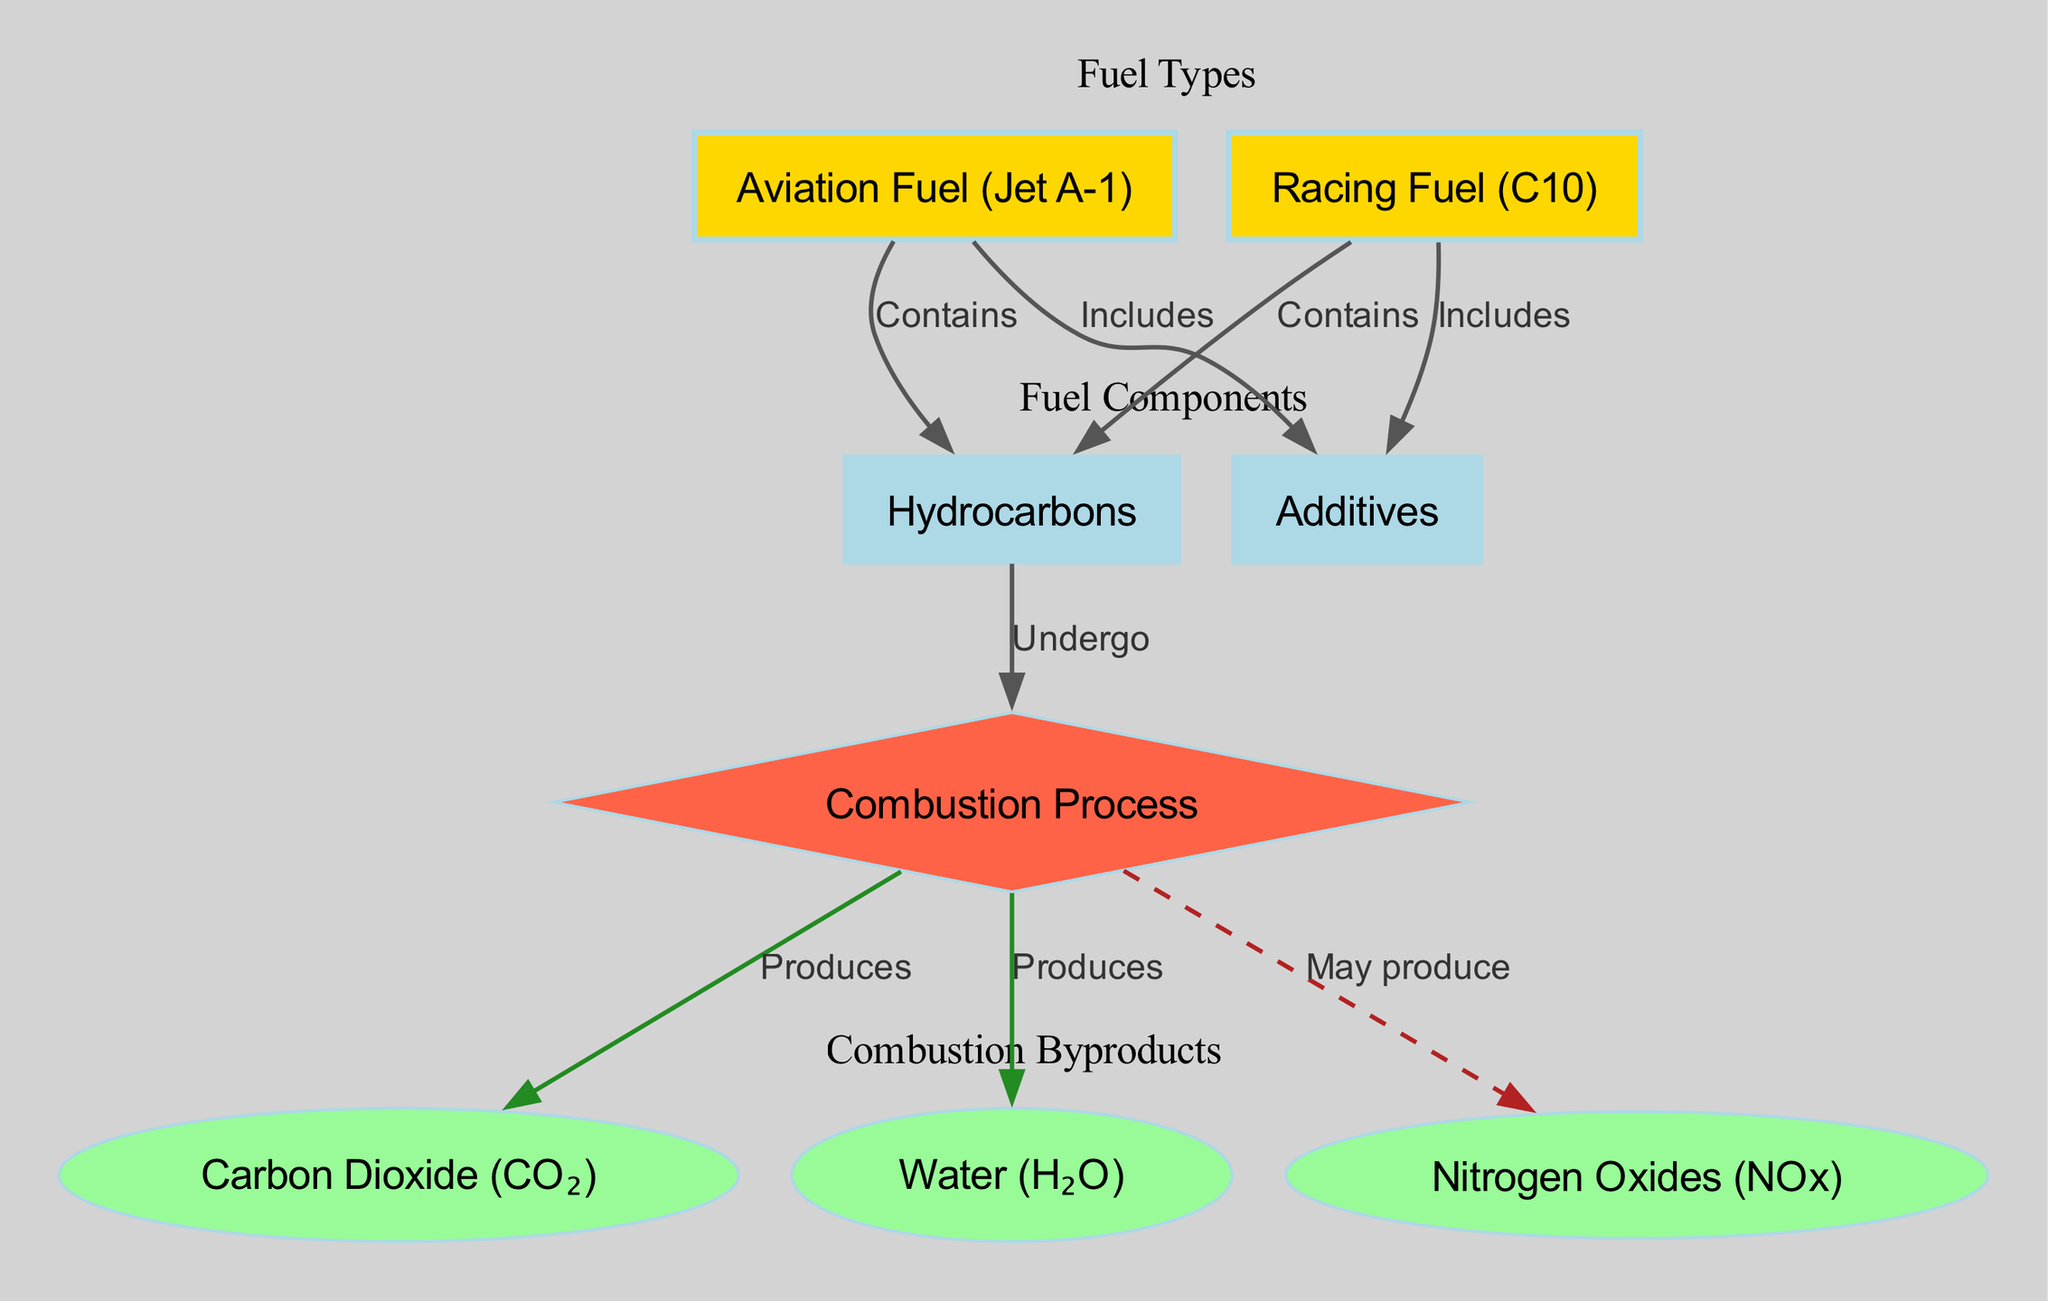What types of fuel are included in the diagram? The diagram lists two types of fuel: Aviation Fuel (Jet A-1) and Racing Fuel (C10). These nodes are distinct and clearly labeled.
Answer: Aviation Fuel (Jet A-1) and Racing Fuel (C10) How many components are included in the fuel types? The diagram includes two components for the fuel types: Hydrocarbons and Additives. Each fuel type is linked to these components.
Answer: Two What byproducts are produced by the combustion process? The combustion process produces Carbon Dioxide (CO₂), Water (H₂O), and may produce Nitrogen Oxides (NOx). These nodes are connected to the combustion process.
Answer: Carbon Dioxide (CO₂), Water (H₂O), Nitrogen Oxides (NOx) Which fuel type includes additives in its composition? Both Aviation Fuel (Jet A-1) and Racing Fuel (C10) include Additives. The diagram explicitly shows this relationship in the edges connecting to the Additives node.
Answer: Aviation Fuel (Jet A-1) and Racing Fuel (C10) What does hydrocarbons undergo during the combustion process? Hydrocarbons undergo combustion according to the edge that connects the Hydrocarbons node to the Combustion Process node. This indicates that combustion is a reaction involving hydrocarbons.
Answer: Combustion How many produces edges are there in the diagram? There are three edges labeled as "Produces" in the diagram, connecting the Combustion Process node to the byproducts Carbon Dioxide (CO₂) and Water (H₂O).
Answer: Three Which byproduct may be produced according to the diagram? The diagram indicates that Nitrogen Oxides (NOx) may be produced during the combustion process, as shown by the dashed edge labeled "May produce."
Answer: Nitrogen Oxides (NOx) What is the connection between racing fuel and hydrocarbons? The connection between Racing Fuel (C10) and Hydrocarbons is that Racing Fuel contains Hydrocarbons, as indicated by the labeled edge.
Answer: Contains What color is used to style the combustion node in the diagram? The combustion node is styled as a diamond and filled with the color tomato, which is visually distinct from other nodes on the diagram.
Answer: Tomato 